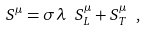<formula> <loc_0><loc_0><loc_500><loc_500>S ^ { \mu } = \sigma \lambda \ S _ { L } ^ { \mu } + S _ { T } ^ { \mu } \ ,</formula> 